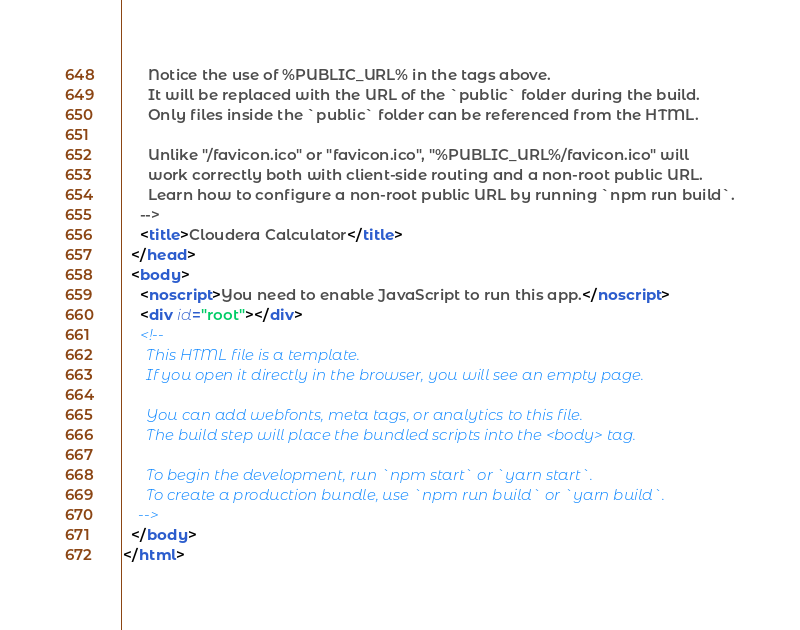Convert code to text. <code><loc_0><loc_0><loc_500><loc_500><_HTML_>      Notice the use of %PUBLIC_URL% in the tags above.
      It will be replaced with the URL of the `public` folder during the build.
      Only files inside the `public` folder can be referenced from the HTML.

      Unlike "/favicon.ico" or "favicon.ico", "%PUBLIC_URL%/favicon.ico" will
      work correctly both with client-side routing and a non-root public URL.
      Learn how to configure a non-root public URL by running `npm run build`.
    -->
    <title>Cloudera Calculator</title>
  </head>
  <body>
    <noscript>You need to enable JavaScript to run this app.</noscript>
    <div id="root"></div>
    <!--
      This HTML file is a template.
      If you open it directly in the browser, you will see an empty page.

      You can add webfonts, meta tags, or analytics to this file.
      The build step will place the bundled scripts into the <body> tag.

      To begin the development, run `npm start` or `yarn start`.
      To create a production bundle, use `npm run build` or `yarn build`.
    -->
  </body>
</html>
</code> 